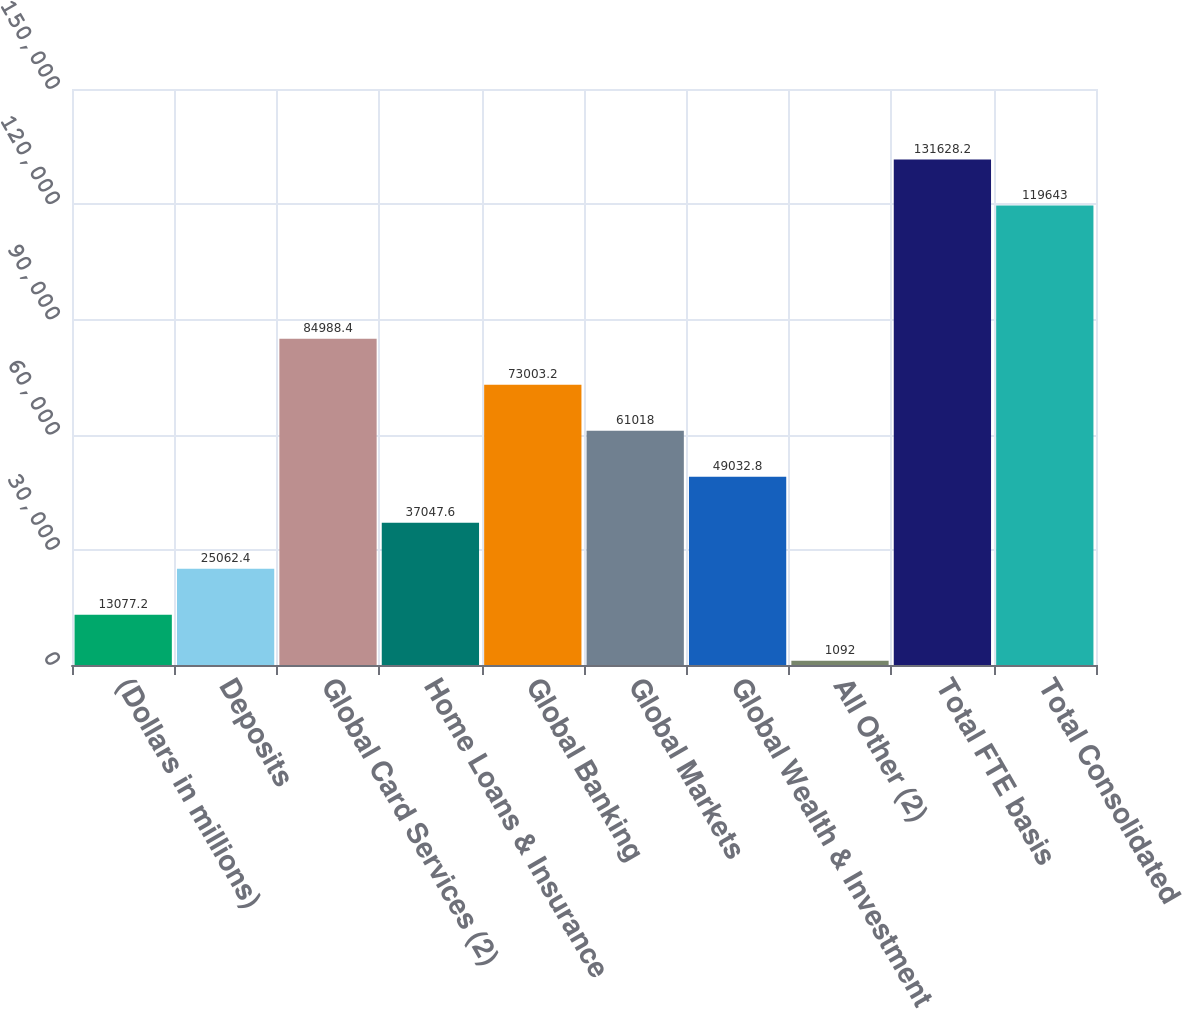<chart> <loc_0><loc_0><loc_500><loc_500><bar_chart><fcel>(Dollars in millions)<fcel>Deposits<fcel>Global Card Services (2)<fcel>Home Loans & Insurance<fcel>Global Banking<fcel>Global Markets<fcel>Global Wealth & Investment<fcel>All Other (2)<fcel>Total FTE basis<fcel>Total Consolidated<nl><fcel>13077.2<fcel>25062.4<fcel>84988.4<fcel>37047.6<fcel>73003.2<fcel>61018<fcel>49032.8<fcel>1092<fcel>131628<fcel>119643<nl></chart> 